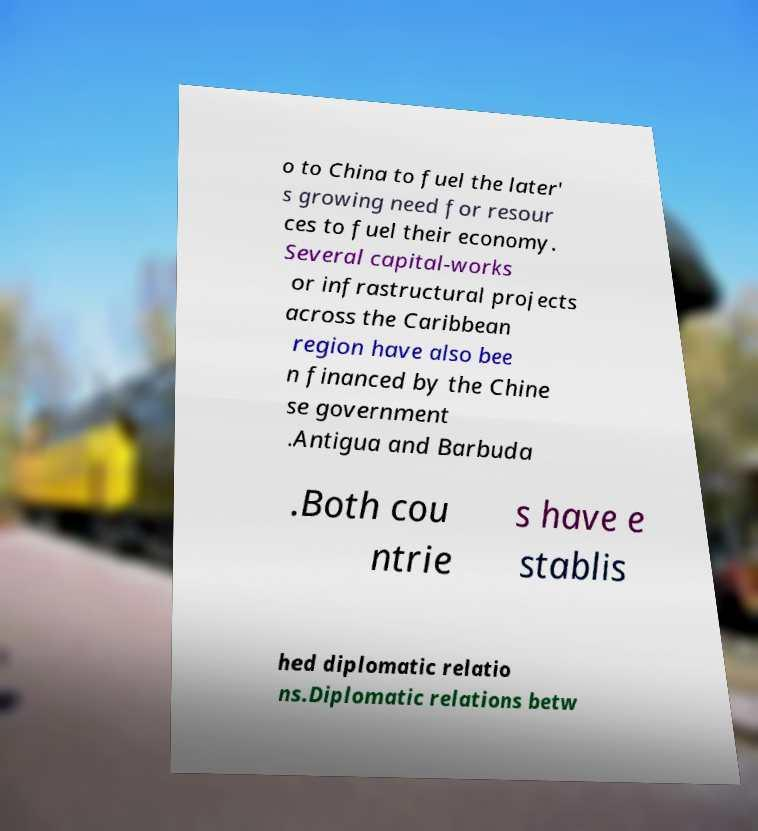For documentation purposes, I need the text within this image transcribed. Could you provide that? o to China to fuel the later' s growing need for resour ces to fuel their economy. Several capital-works or infrastructural projects across the Caribbean region have also bee n financed by the Chine se government .Antigua and Barbuda .Both cou ntrie s have e stablis hed diplomatic relatio ns.Diplomatic relations betw 